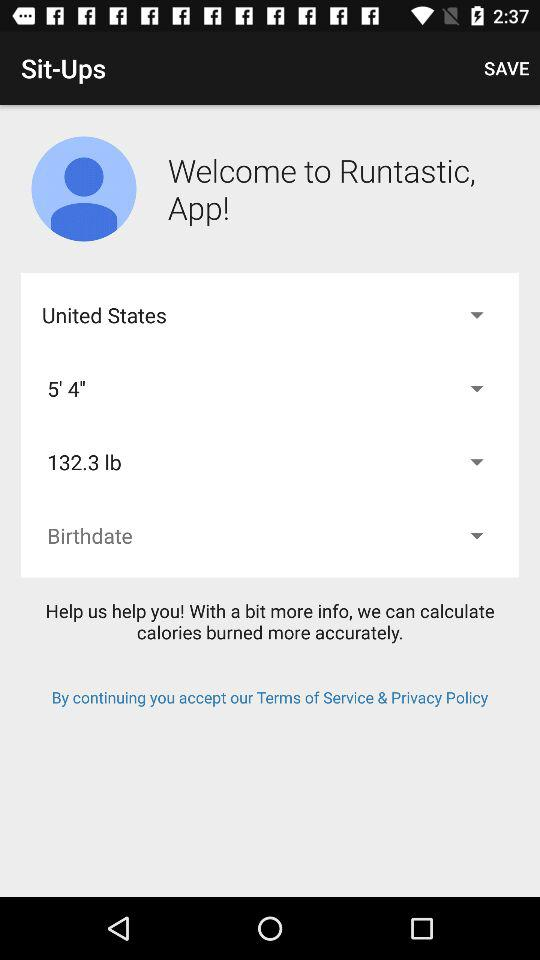What is the weight? The weight is 132.3 lb. 